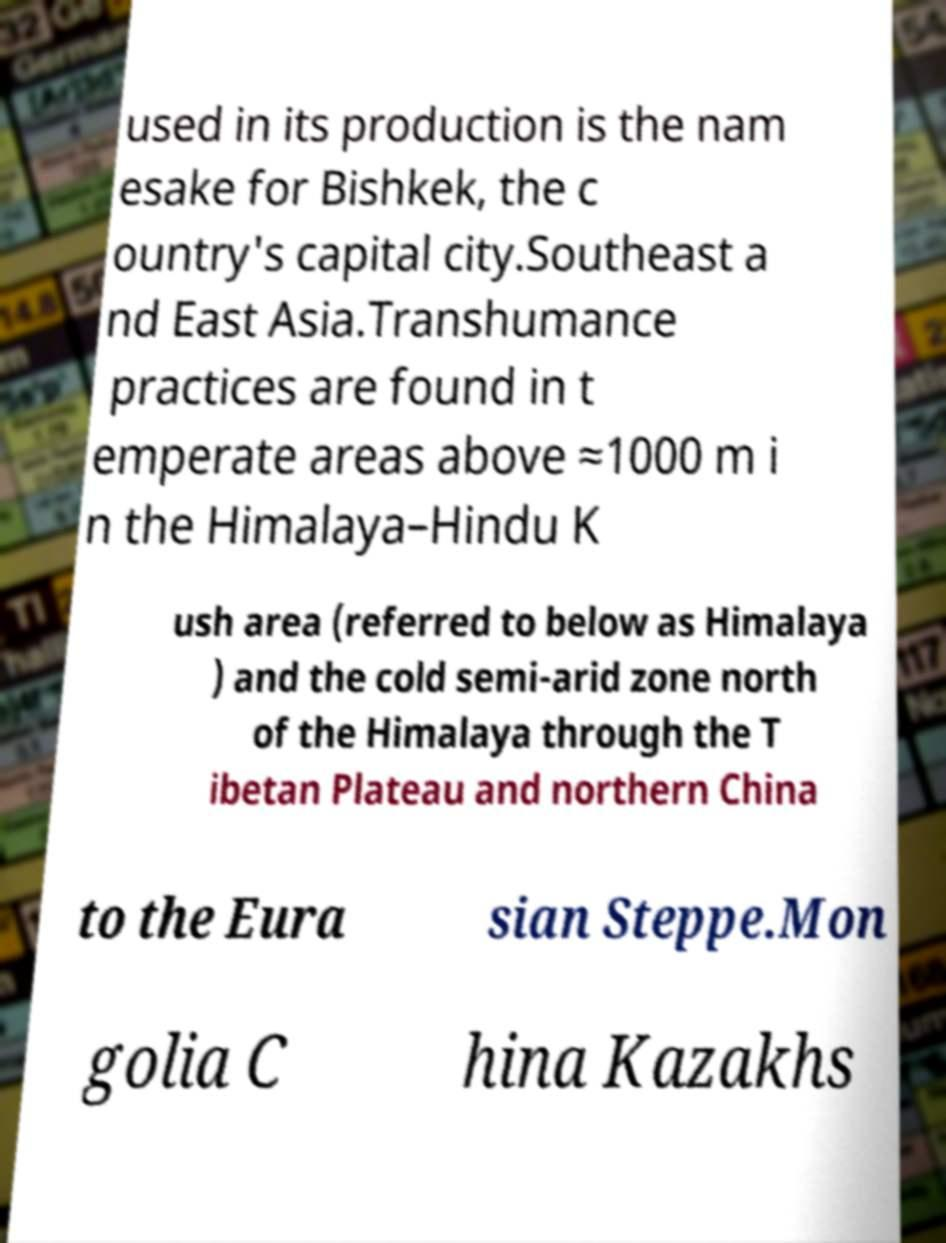Could you assist in decoding the text presented in this image and type it out clearly? used in its production is the nam esake for Bishkek, the c ountry's capital city.Southeast a nd East Asia.Transhumance practices are found in t emperate areas above ≈1000 m i n the Himalaya–Hindu K ush area (referred to below as Himalaya ) and the cold semi-arid zone north of the Himalaya through the T ibetan Plateau and northern China to the Eura sian Steppe.Mon golia C hina Kazakhs 